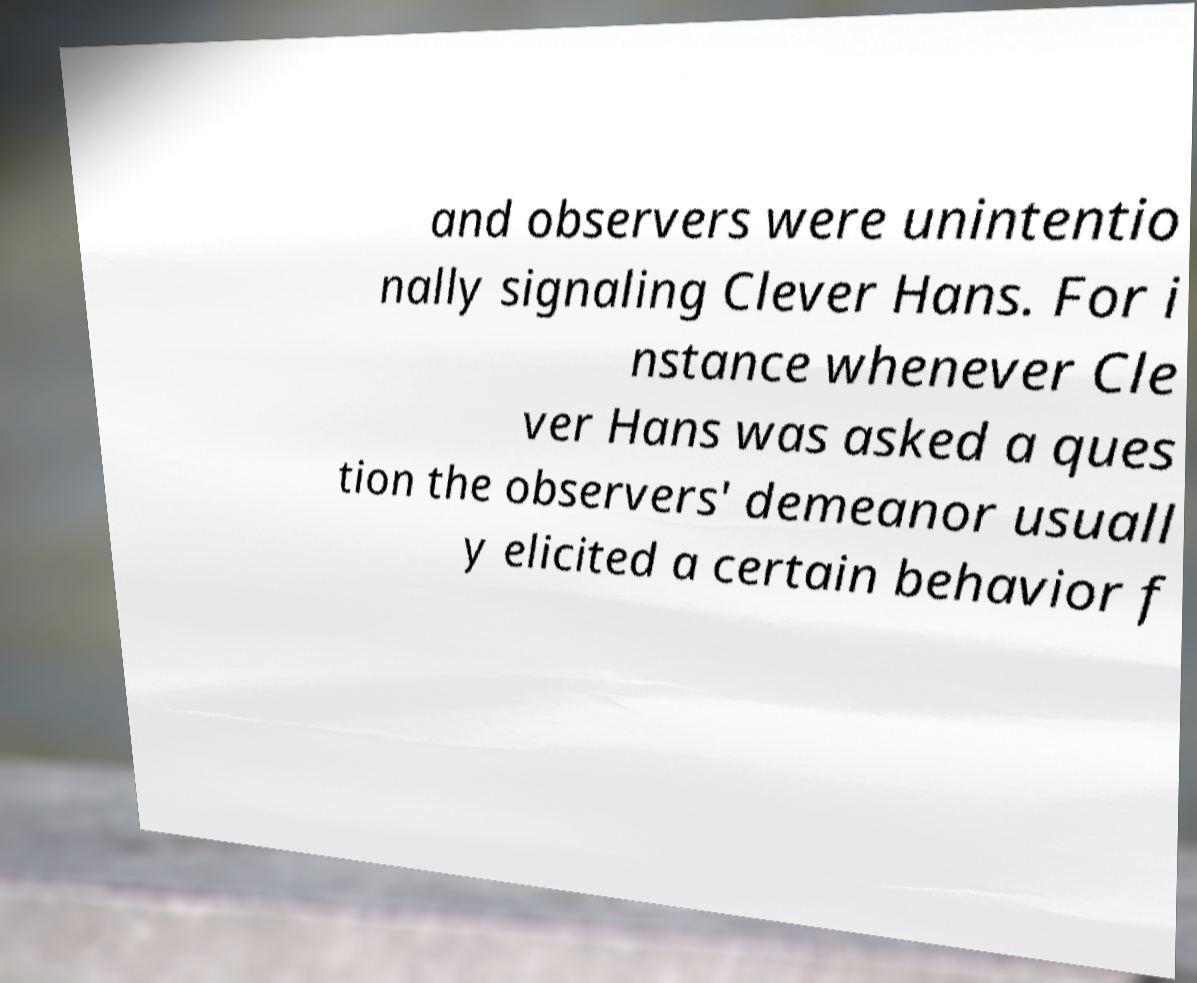Can you read and provide the text displayed in the image?This photo seems to have some interesting text. Can you extract and type it out for me? and observers were unintentio nally signaling Clever Hans. For i nstance whenever Cle ver Hans was asked a ques tion the observers' demeanor usuall y elicited a certain behavior f 